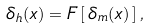<formula> <loc_0><loc_0><loc_500><loc_500>\delta _ { h } ( x ) = F \left [ \, \delta _ { m } ( x ) \, \right ] ,</formula> 